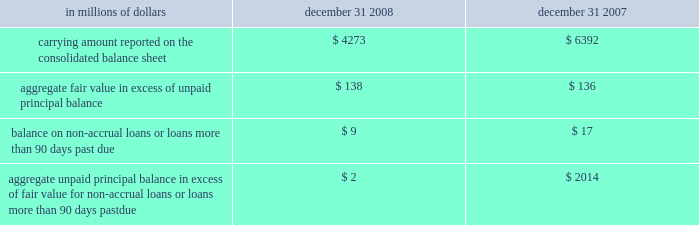The company has elected the fair-value option where the interest-rate risk of such liabilities is economically hedged with derivative contracts or the proceeds are used to purchase financial assets that will also be accounted for at fair value through earnings .
The election has been made to mitigate accounting mismatches and to achieve operational simplifications .
These positions are reported in short-term borrowings and long-term debt on the company 2019s consolidated balance sheet .
The majority of these non-structured liabilities are a result of the company 2019s election of the fair-value option for liabilities associated with the citi-advised structured investment vehicles ( sivs ) , which were consolidated during the fourth quarter of 2007 .
The change in fair values of the sivs 2019 liabilities reported in earnings was $ 2.6 billion for the year ended december 31 , 2008 .
For these non-structured liabilities the aggregate fair value is $ 263 million lower than the aggregate unpaid principal balance as of december 31 , 2008 .
For all other non-structured liabilities classified as long-term debt for which the fair-value option has been elected , the aggregate unpaid principal balance exceeds the aggregate fair value of such instruments by $ 97 million as of december 31 , 2008 while the aggregate fair value exceeded the aggregate unpaid principal by $ 112 million as of december 31 , 2007 .
The change in fair value of these non-structured liabilities reported a gain of $ 1.2 billion for the year ended december 31 , 2008 .
The change in fair value for these non-structured liabilities is reported in principal transactions in the company 2019s consolidated statement of income .
Related interest expense continues to be measured based on the contractual interest rates and reported as such in the consolidated income statement .
Certain mortgage loans citigroup has elected the fair-value option for certain purchased and originated prime fixed-rate and conforming adjustable-rate first mortgage loans held-for- sale .
These loans are intended for sale or securitization and are hedged with derivative instruments .
The company has elected the fair-value option to mitigate accounting mismatches in cases where hedge accounting is complex and to achieve operational simplifications .
The fair-value option was not elected for loans held-for-investment , as those loans are not hedged with derivative instruments .
This election was effective for applicable instruments originated or purchased on or after september 1 , 2007 .
The table provides information about certain mortgage loans carried at fair value : in millions of dollars december 31 , december 31 , carrying amount reported on the consolidated balance sheet $ 4273 $ 6392 aggregate fair value in excess of unpaid principal balance $ 138 $ 136 balance on non-accrual loans or loans more than 90 days past due $ 9 $ 17 aggregate unpaid principal balance in excess of fair value for non-accrual loans or loans more than 90 days past due $ 2 $ 2014 the changes in fair values of these mortgage loans is reported in other revenue in the company 2019s consolidated statement of income .
The changes in fair value during the year ended december 31 , 2008 due to instrument- specific credit risk resulted in a $ 32 million loss .
The change in fair value during 2007 due to instrument-specific credit risk was immaterial .
Related interest income continues to be measured based on the contractual interest rates and reported as such in the consolidated income statement .
Items selected for fair-value accounting in accordance with sfas 155 and sfas 156 certain hybrid financial instruments the company has elected to apply fair-value accounting under sfas 155 for certain hybrid financial assets and liabilities whose performance is linked to risks other than interest rate , foreign exchange or inflation ( e.g. , equity , credit or commodity risks ) .
In addition , the company has elected fair-value accounting under sfas 155 for residual interests retained from securitizing certain financial assets .
The company has elected fair-value accounting for these instruments because these exposures are considered to be trading-related positions and , therefore , are managed on a fair-value basis .
In addition , the accounting for these instruments is simplified under a fair-value approach as it eliminates the complicated operational requirements of bifurcating the embedded derivatives from the host contracts and accounting for each separately .
The hybrid financial instruments are classified as trading account assets , loans , deposits , trading account liabilities ( for prepaid derivatives ) , short-term borrowings or long-term debt on the company 2019s consolidated balance sheet according to their legal form , while residual interests in certain securitizations are classified as trading account assets .
For hybrid financial instruments for which fair-value accounting has been elected under sfas 155 and that are classified as long-term debt , the aggregate unpaid principal exceeds the aggregate fair value by $ 1.9 billion as of december 31 , 2008 , while the aggregate fair value exceeds the aggregate unpaid principal balance by $ 460 million as of december 31 , 2007 .
The difference for those instruments classified as loans is immaterial .
Changes in fair value for hybrid financial instruments , which in most cases includes a component for accrued interest , are recorded in principal transactions in the company 2019s consolidated statement of income .
Interest accruals for certain hybrid instruments classified as trading assets are recorded separately from the change in fair value as interest revenue in the company 2019s consolidated statement of income .
Mortgage servicing rights the company accounts for mortgage servicing rights ( msrs ) at fair value in accordance with sfas 156 .
Fair value for msrs is determined using an option-adjusted spread valuation approach .
This approach consists of projecting servicing cash flows under multiple interest-rate scenarios and discounting these cash flows using risk-adjusted rates .
The model assumptions used in the valuation of msrs include mortgage prepayment speeds and discount rates .
The fair value of msrs is primarily affected by changes in prepayments that result from shifts in mortgage interest rates .
In managing this risk , the company hedges a significant portion of the values of its msrs through the use of interest-rate derivative contracts , forward- purchase commitments of mortgage-backed securities , and purchased securities classified as trading .
See note 23 on page 175 for further discussions regarding the accounting and reporting of msrs .
These msrs , which totaled $ 5.7 billion and $ 8.4 billion as of december 31 , 2008 and december 31 , 2007 , respectively , are classified as mortgage servicing rights on citigroup 2019s consolidated balance sheet .
Changes in fair value of msrs are recorded in commissions and fees in the company 2019s consolidated statement of income. .
The company has elected the fair-value option where the interest-rate risk of such liabilities is economically hedged with derivative contracts or the proceeds are used to purchase financial assets that will also be accounted for at fair value through earnings .
The election has been made to mitigate accounting mismatches and to achieve operational simplifications .
These positions are reported in short-term borrowings and long-term debt on the company 2019s consolidated balance sheet .
The majority of these non-structured liabilities are a result of the company 2019s election of the fair-value option for liabilities associated with the citi-advised structured investment vehicles ( sivs ) , which were consolidated during the fourth quarter of 2007 .
The change in fair values of the sivs 2019 liabilities reported in earnings was $ 2.6 billion for the year ended december 31 , 2008 .
For these non-structured liabilities the aggregate fair value is $ 263 million lower than the aggregate unpaid principal balance as of december 31 , 2008 .
For all other non-structured liabilities classified as long-term debt for which the fair-value option has been elected , the aggregate unpaid principal balance exceeds the aggregate fair value of such instruments by $ 97 million as of december 31 , 2008 while the aggregate fair value exceeded the aggregate unpaid principal by $ 112 million as of december 31 , 2007 .
The change in fair value of these non-structured liabilities reported a gain of $ 1.2 billion for the year ended december 31 , 2008 .
The change in fair value for these non-structured liabilities is reported in principal transactions in the company 2019s consolidated statement of income .
Related interest expense continues to be measured based on the contractual interest rates and reported as such in the consolidated income statement .
Certain mortgage loans citigroup has elected the fair-value option for certain purchased and originated prime fixed-rate and conforming adjustable-rate first mortgage loans held-for- sale .
These loans are intended for sale or securitization and are hedged with derivative instruments .
The company has elected the fair-value option to mitigate accounting mismatches in cases where hedge accounting is complex and to achieve operational simplifications .
The fair-value option was not elected for loans held-for-investment , as those loans are not hedged with derivative instruments .
This election was effective for applicable instruments originated or purchased on or after september 1 , 2007 .
The following table provides information about certain mortgage loans carried at fair value : in millions of dollars december 31 , december 31 , carrying amount reported on the consolidated balance sheet $ 4273 $ 6392 aggregate fair value in excess of unpaid principal balance $ 138 $ 136 balance on non-accrual loans or loans more than 90 days past due $ 9 $ 17 aggregate unpaid principal balance in excess of fair value for non-accrual loans or loans more than 90 days past due $ 2 $ 2014 the changes in fair values of these mortgage loans is reported in other revenue in the company 2019s consolidated statement of income .
The changes in fair value during the year ended december 31 , 2008 due to instrument- specific credit risk resulted in a $ 32 million loss .
The change in fair value during 2007 due to instrument-specific credit risk was immaterial .
Related interest income continues to be measured based on the contractual interest rates and reported as such in the consolidated income statement .
Items selected for fair-value accounting in accordance with sfas 155 and sfas 156 certain hybrid financial instruments the company has elected to apply fair-value accounting under sfas 155 for certain hybrid financial assets and liabilities whose performance is linked to risks other than interest rate , foreign exchange or inflation ( e.g. , equity , credit or commodity risks ) .
In addition , the company has elected fair-value accounting under sfas 155 for residual interests retained from securitizing certain financial assets .
The company has elected fair-value accounting for these instruments because these exposures are considered to be trading-related positions and , therefore , are managed on a fair-value basis .
In addition , the accounting for these instruments is simplified under a fair-value approach as it eliminates the complicated operational requirements of bifurcating the embedded derivatives from the host contracts and accounting for each separately .
The hybrid financial instruments are classified as trading account assets , loans , deposits , trading account liabilities ( for prepaid derivatives ) , short-term borrowings or long-term debt on the company 2019s consolidated balance sheet according to their legal form , while residual interests in certain securitizations are classified as trading account assets .
For hybrid financial instruments for which fair-value accounting has been elected under sfas 155 and that are classified as long-term debt , the aggregate unpaid principal exceeds the aggregate fair value by $ 1.9 billion as of december 31 , 2008 , while the aggregate fair value exceeds the aggregate unpaid principal balance by $ 460 million as of december 31 , 2007 .
The difference for those instruments classified as loans is immaterial .
Changes in fair value for hybrid financial instruments , which in most cases includes a component for accrued interest , are recorded in principal transactions in the company 2019s consolidated statement of income .
Interest accruals for certain hybrid instruments classified as trading assets are recorded separately from the change in fair value as interest revenue in the company 2019s consolidated statement of income .
Mortgage servicing rights the company accounts for mortgage servicing rights ( msrs ) at fair value in accordance with sfas 156 .
Fair value for msrs is determined using an option-adjusted spread valuation approach .
This approach consists of projecting servicing cash flows under multiple interest-rate scenarios and discounting these cash flows using risk-adjusted rates .
The model assumptions used in the valuation of msrs include mortgage prepayment speeds and discount rates .
The fair value of msrs is primarily affected by changes in prepayments that result from shifts in mortgage interest rates .
In managing this risk , the company hedges a significant portion of the values of its msrs through the use of interest-rate derivative contracts , forward- purchase commitments of mortgage-backed securities , and purchased securities classified as trading .
See note 23 on page 175 for further discussions regarding the accounting and reporting of msrs .
These msrs , which totaled $ 5.7 billion and $ 8.4 billion as of december 31 , 2008 and december 31 , 2007 , respectively , are classified as mortgage servicing rights on citigroup 2019s consolidated balance sheet .
Changes in fair value of msrs are recorded in commissions and fees in the company 2019s consolidated statement of income. .
On the citigroup 2019s consolidated balance sheet what was the ratio of the mortgage servicing rights ( msrs ) fro 2008 compared to 2007? 
Rationale: on the citigroup 2019s consolidated balance sheet there was $ 0.68 of ( msrs ) for 2008 compared per $ 1 2007
Computations: (5.7 / 8.4)
Answer: 0.67857. 